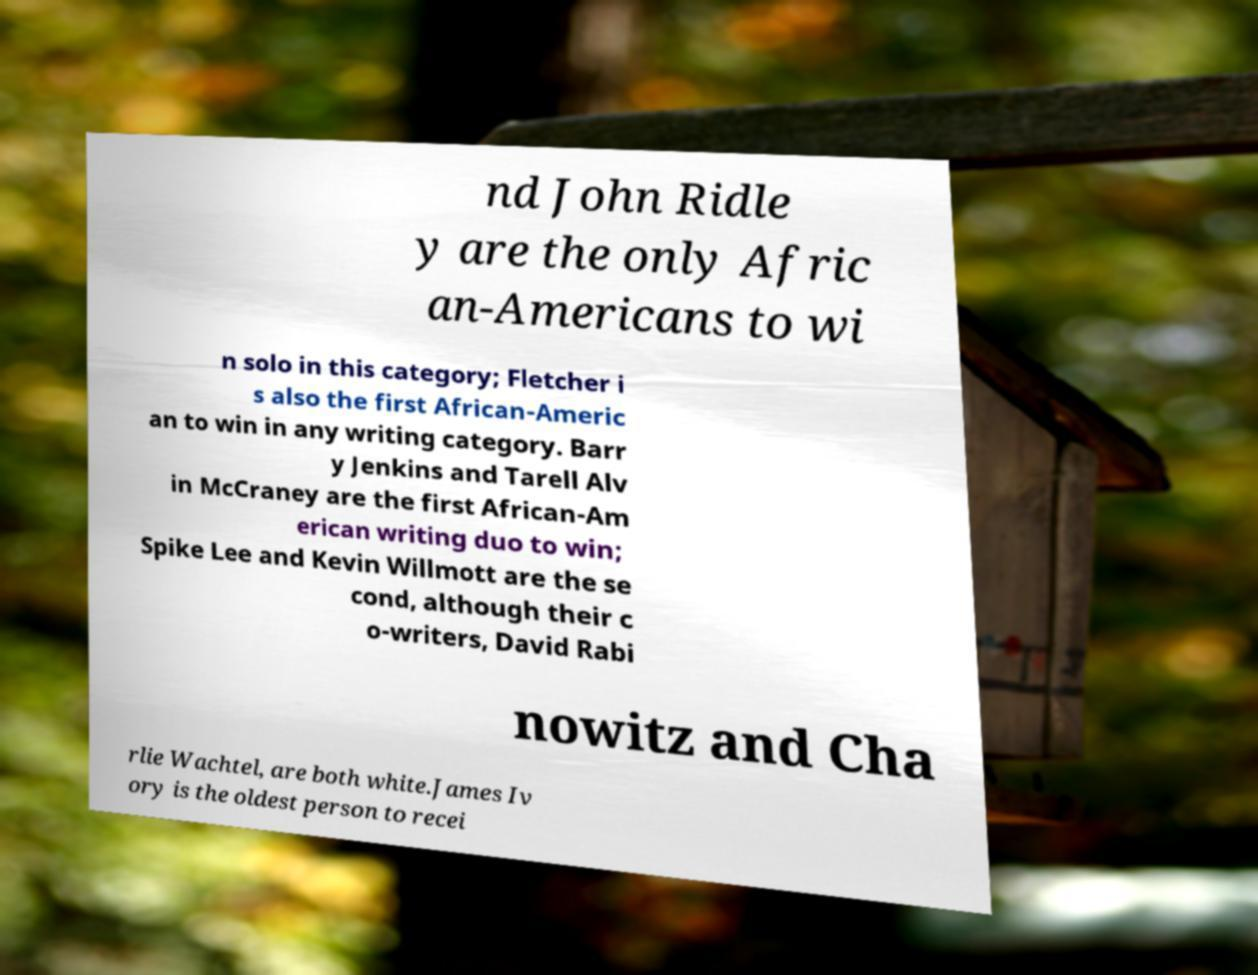Please identify and transcribe the text found in this image. nd John Ridle y are the only Afric an-Americans to wi n solo in this category; Fletcher i s also the first African-Americ an to win in any writing category. Barr y Jenkins and Tarell Alv in McCraney are the first African-Am erican writing duo to win; Spike Lee and Kevin Willmott are the se cond, although their c o-writers, David Rabi nowitz and Cha rlie Wachtel, are both white.James Iv ory is the oldest person to recei 